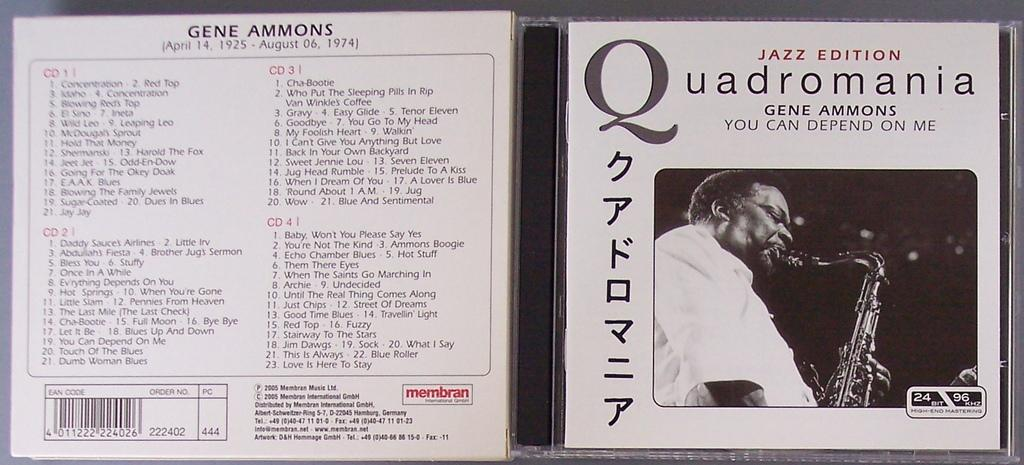<image>
Relay a brief, clear account of the picture shown. open cd case from quadromania by gene ammons 